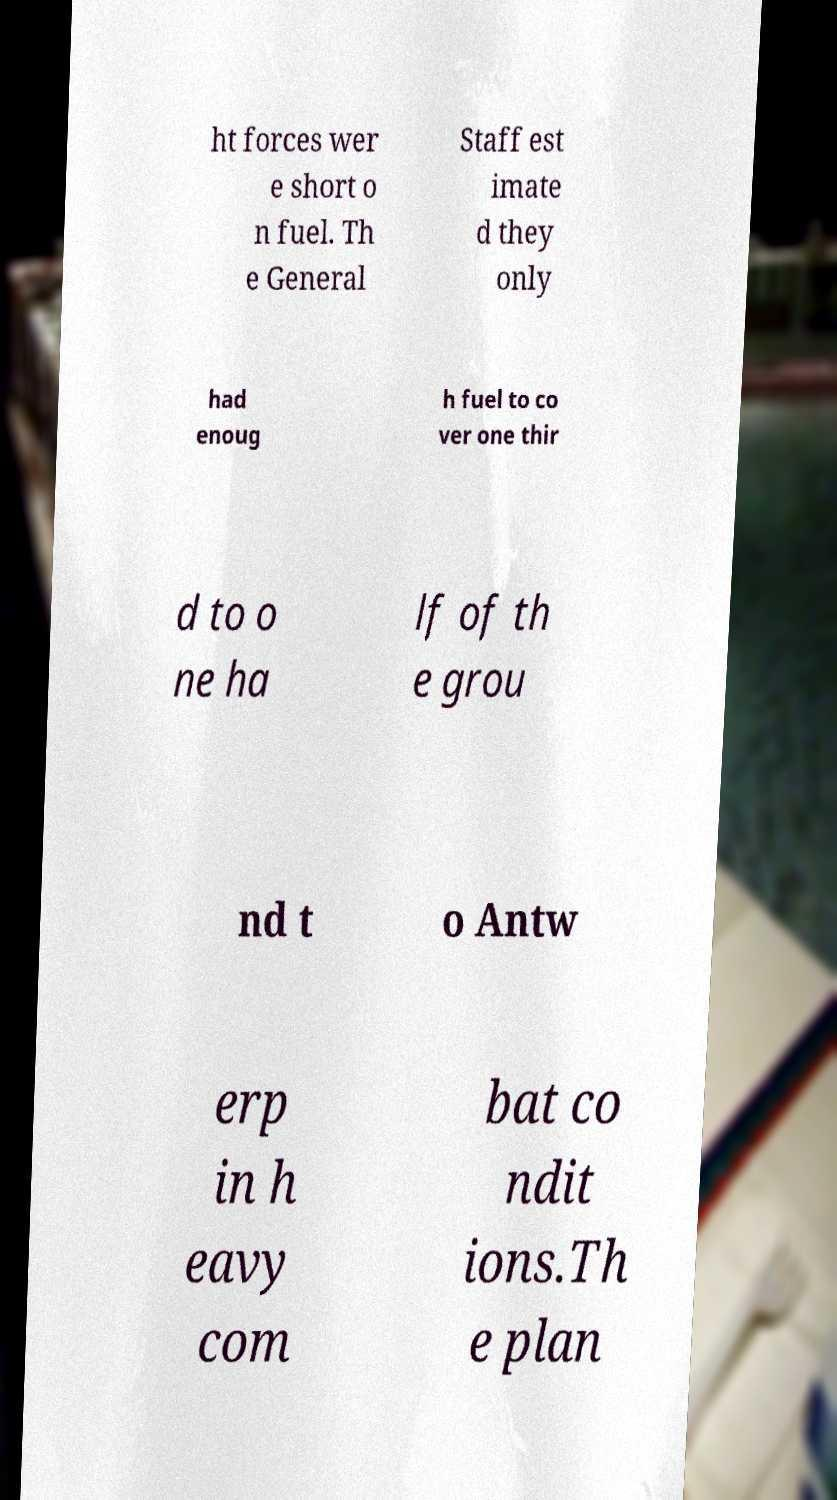Please identify and transcribe the text found in this image. ht forces wer e short o n fuel. Th e General Staff est imate d they only had enoug h fuel to co ver one thir d to o ne ha lf of th e grou nd t o Antw erp in h eavy com bat co ndit ions.Th e plan 